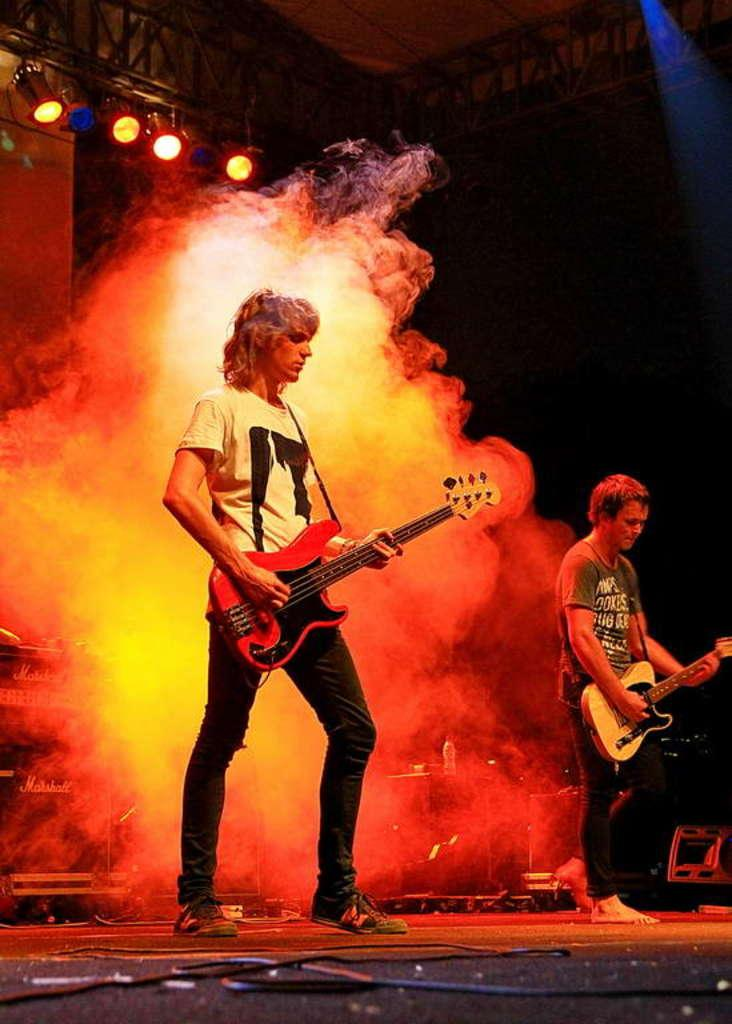What can be seen at the top of the image? There are lights visible at the top of the image. What are the two men in the image doing? The men are standing on a platform and playing guitar. What is the source of the smoke visible behind the men? The source of the smoke is not specified in the image. What is the purpose of the wire in the image? The purpose of the wire is not specified in the image. Can you see the toes of the men playing guitar in the image? There is no indication of the men's toes in the image, as they are standing on a platform and playing guitar. Is there a bomb visible in the image? There is no bomb present in the image. What type of drum is being played in the image? There is no drum present in the image; the men are playing guitar. 